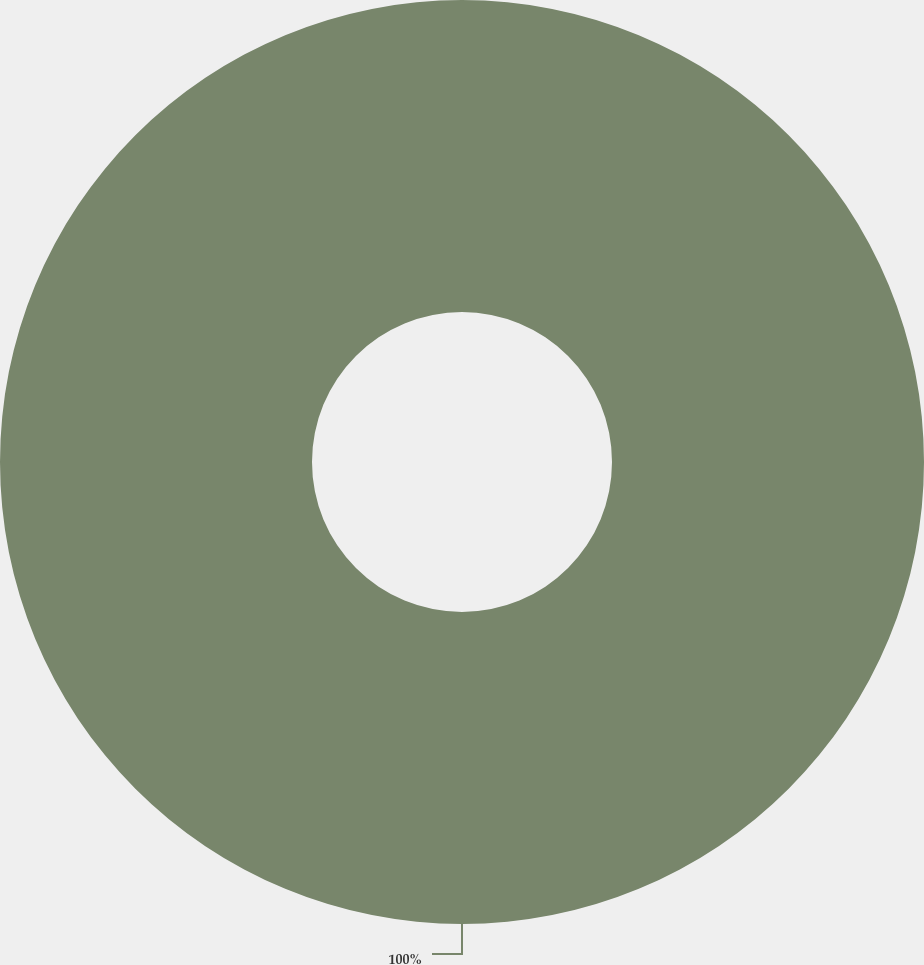<chart> <loc_0><loc_0><loc_500><loc_500><pie_chart><ecel><nl><fcel>100.0%<nl></chart> 